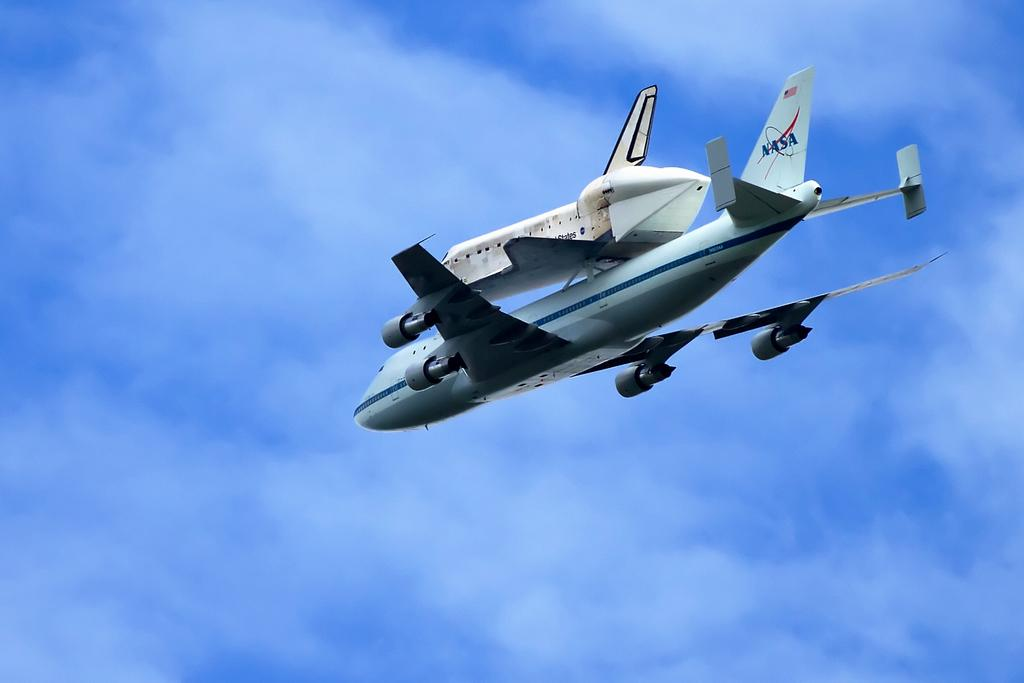What is the main subject of the picture? The main subject of the picture is an airplane. What is the color of the airplane? The airplane is white in color. What is the airplane doing in the picture? The airplane is flying in the sky. What can be seen in the background of the image? The sky is visible in the background of the image. What is the color of the sky in the image? The sky is blue in color. What type of title can be seen on the airplane in the image? There is no title visible on the airplane in the image. How many visitors are present in the image? There are no visitors present in the image; it only features an airplane flying in the sky. 